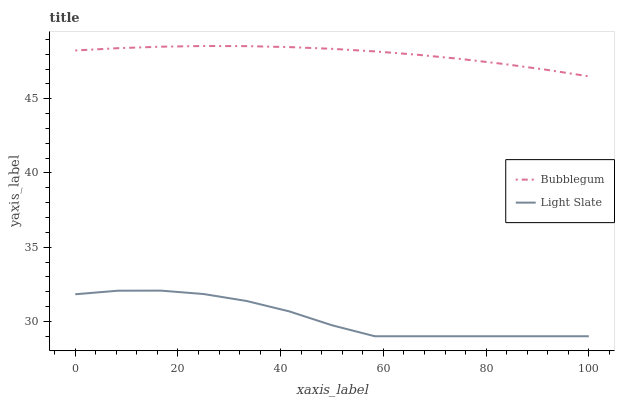Does Light Slate have the minimum area under the curve?
Answer yes or no. Yes. Does Bubblegum have the maximum area under the curve?
Answer yes or no. Yes. Does Bubblegum have the minimum area under the curve?
Answer yes or no. No. Is Bubblegum the smoothest?
Answer yes or no. Yes. Is Light Slate the roughest?
Answer yes or no. Yes. Is Bubblegum the roughest?
Answer yes or no. No. Does Light Slate have the lowest value?
Answer yes or no. Yes. Does Bubblegum have the lowest value?
Answer yes or no. No. Does Bubblegum have the highest value?
Answer yes or no. Yes. Is Light Slate less than Bubblegum?
Answer yes or no. Yes. Is Bubblegum greater than Light Slate?
Answer yes or no. Yes. Does Light Slate intersect Bubblegum?
Answer yes or no. No. 